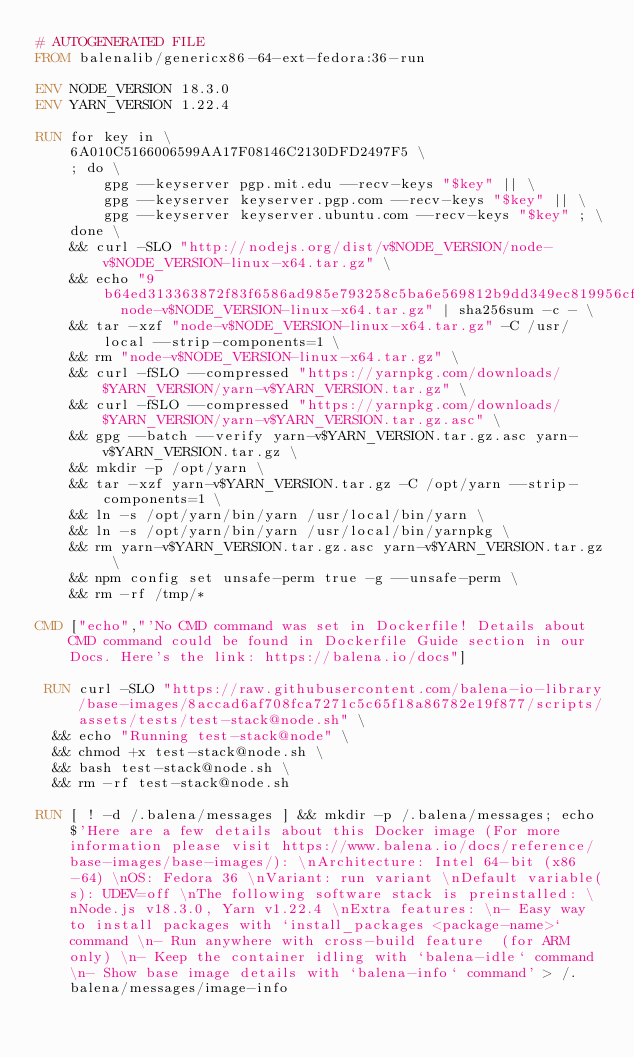<code> <loc_0><loc_0><loc_500><loc_500><_Dockerfile_># AUTOGENERATED FILE
FROM balenalib/genericx86-64-ext-fedora:36-run

ENV NODE_VERSION 18.3.0
ENV YARN_VERSION 1.22.4

RUN for key in \
	6A010C5166006599AA17F08146C2130DFD2497F5 \
	; do \
		gpg --keyserver pgp.mit.edu --recv-keys "$key" || \
		gpg --keyserver keyserver.pgp.com --recv-keys "$key" || \
		gpg --keyserver keyserver.ubuntu.com --recv-keys "$key" ; \
	done \
	&& curl -SLO "http://nodejs.org/dist/v$NODE_VERSION/node-v$NODE_VERSION-linux-x64.tar.gz" \
	&& echo "9b64ed313363872f83f6586ad985e793258c5ba6e569812b9dd349ec819956cf  node-v$NODE_VERSION-linux-x64.tar.gz" | sha256sum -c - \
	&& tar -xzf "node-v$NODE_VERSION-linux-x64.tar.gz" -C /usr/local --strip-components=1 \
	&& rm "node-v$NODE_VERSION-linux-x64.tar.gz" \
	&& curl -fSLO --compressed "https://yarnpkg.com/downloads/$YARN_VERSION/yarn-v$YARN_VERSION.tar.gz" \
	&& curl -fSLO --compressed "https://yarnpkg.com/downloads/$YARN_VERSION/yarn-v$YARN_VERSION.tar.gz.asc" \
	&& gpg --batch --verify yarn-v$YARN_VERSION.tar.gz.asc yarn-v$YARN_VERSION.tar.gz \
	&& mkdir -p /opt/yarn \
	&& tar -xzf yarn-v$YARN_VERSION.tar.gz -C /opt/yarn --strip-components=1 \
	&& ln -s /opt/yarn/bin/yarn /usr/local/bin/yarn \
	&& ln -s /opt/yarn/bin/yarn /usr/local/bin/yarnpkg \
	&& rm yarn-v$YARN_VERSION.tar.gz.asc yarn-v$YARN_VERSION.tar.gz \
	&& npm config set unsafe-perm true -g --unsafe-perm \
	&& rm -rf /tmp/*

CMD ["echo","'No CMD command was set in Dockerfile! Details about CMD command could be found in Dockerfile Guide section in our Docs. Here's the link: https://balena.io/docs"]

 RUN curl -SLO "https://raw.githubusercontent.com/balena-io-library/base-images/8accad6af708fca7271c5c65f18a86782e19f877/scripts/assets/tests/test-stack@node.sh" \
  && echo "Running test-stack@node" \
  && chmod +x test-stack@node.sh \
  && bash test-stack@node.sh \
  && rm -rf test-stack@node.sh 

RUN [ ! -d /.balena/messages ] && mkdir -p /.balena/messages; echo $'Here are a few details about this Docker image (For more information please visit https://www.balena.io/docs/reference/base-images/base-images/): \nArchitecture: Intel 64-bit (x86-64) \nOS: Fedora 36 \nVariant: run variant \nDefault variable(s): UDEV=off \nThe following software stack is preinstalled: \nNode.js v18.3.0, Yarn v1.22.4 \nExtra features: \n- Easy way to install packages with `install_packages <package-name>` command \n- Run anywhere with cross-build feature  (for ARM only) \n- Keep the container idling with `balena-idle` command \n- Show base image details with `balena-info` command' > /.balena/messages/image-info</code> 